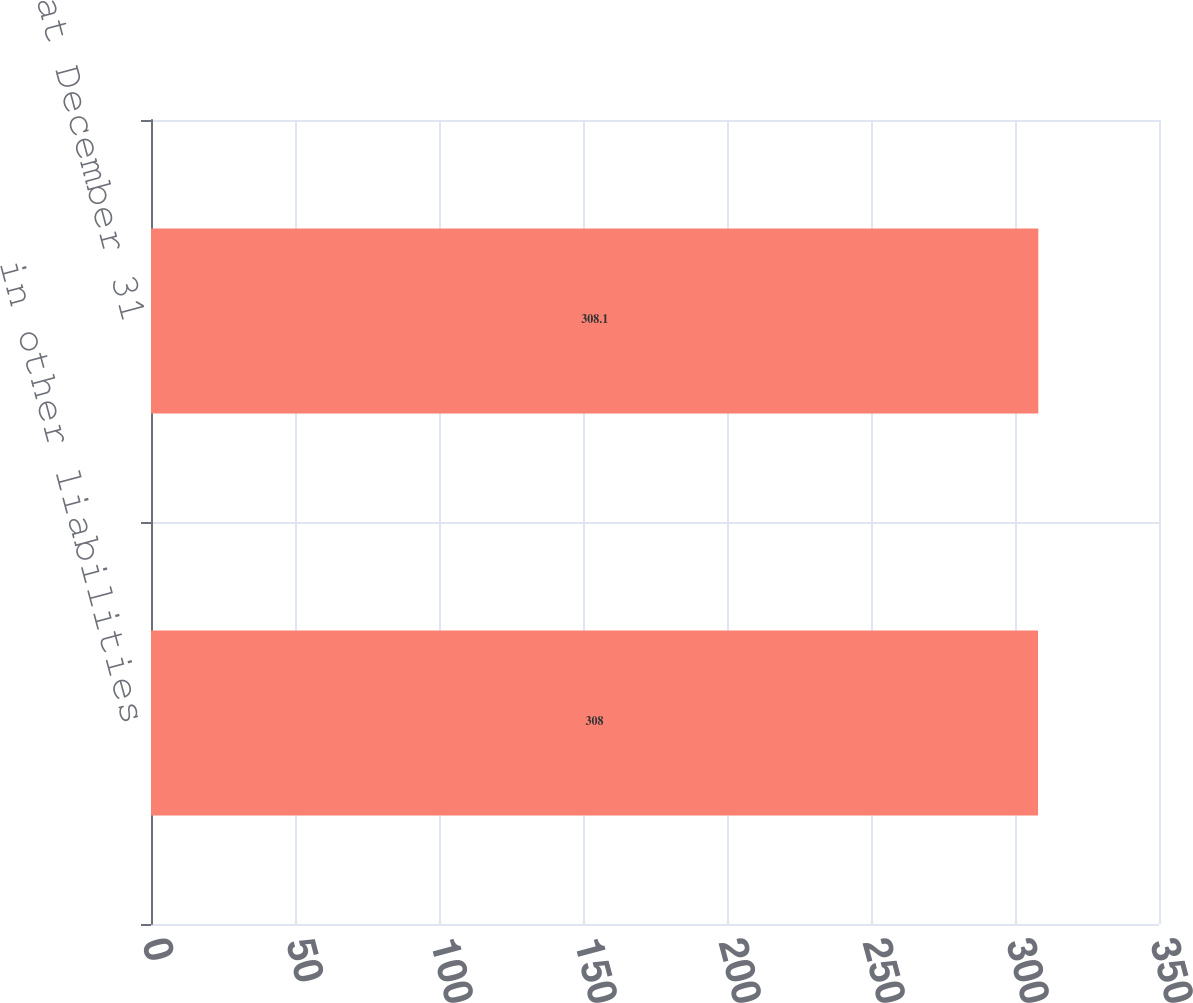<chart> <loc_0><loc_0><loc_500><loc_500><bar_chart><fcel>in other liabilities<fcel>at December 31<nl><fcel>308<fcel>308.1<nl></chart> 